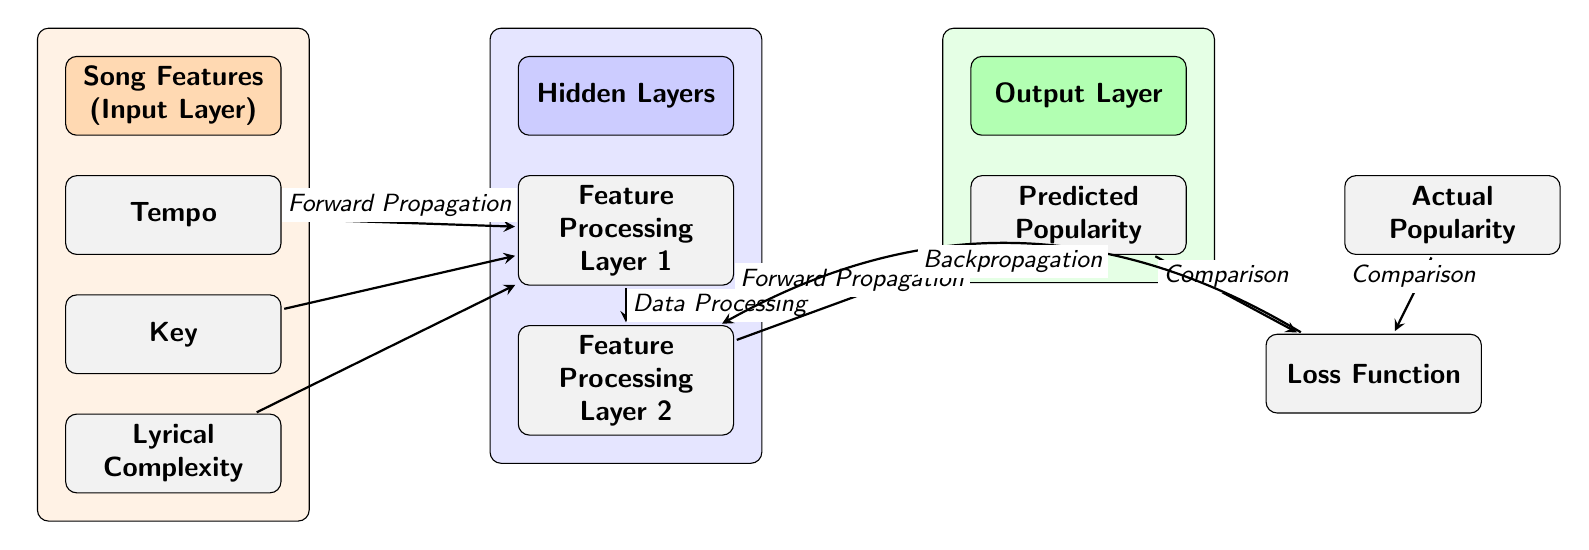What are the three input features? The diagram identifies three input features as Tempo, Key, and Lyrical Complexity, which are listed vertically under the input layer.
Answer: Tempo, Key, Lyrical Complexity How many hidden processing layers are shown? There are two hidden processing layers identified in the diagram, labeled as Feature Processing Layer 1 and Feature Processing Layer 2.
Answer: 2 What is the final output of the neural network? The output layer of the neural network is labeled with Predicted Popularity, which represents the final outcome of the model's predictions based on the processed input features.
Answer: Predicted Popularity What type of function is depicted between predicted and actual popularity? The diagram shows a Loss Function, which compares the predicted popularity against the actual popularity, indicating the model's performance.
Answer: Loss Function How does the output layer connect to the loss function? The diagram illustrates a forward propagation arrow from the Predicted Popularity node to the Loss Function node, indicating that the predicted results are fed into the loss function for evaluation.
Answer: Forward Propagation What is the purpose of the backpropagation arrow in the diagram? The backpropagation arrow connects the Loss Function to the Hidden Layer 2, indicating that errors from the loss function are sent back through the network to update weights and improve predictions.
Answer: Backpropagation How is data processed after the first hidden layer? The diagram shows that there is an arrow indicating data processing that flows from Hidden Layer 1 to Hidden Layer 2, meaning that data undergoes further processing before producing an output.
Answer: Data Processing Which layer is responsible for the prediction of song popularity? The Output Layer, represented as the Predicted Popularity, is responsible for making the final prediction regarding the song's popularity based on the inputs processed through the neural network.
Answer: Output Layer 